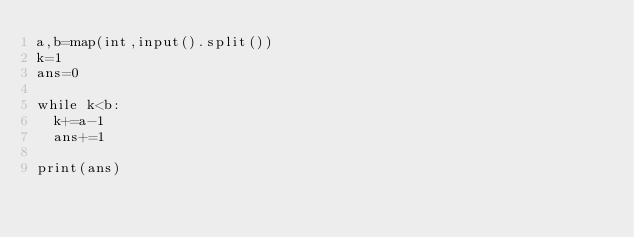<code> <loc_0><loc_0><loc_500><loc_500><_Python_>a,b=map(int,input().split())
k=1
ans=0

while k<b:
  k+=a-1
  ans+=1

print(ans)</code> 